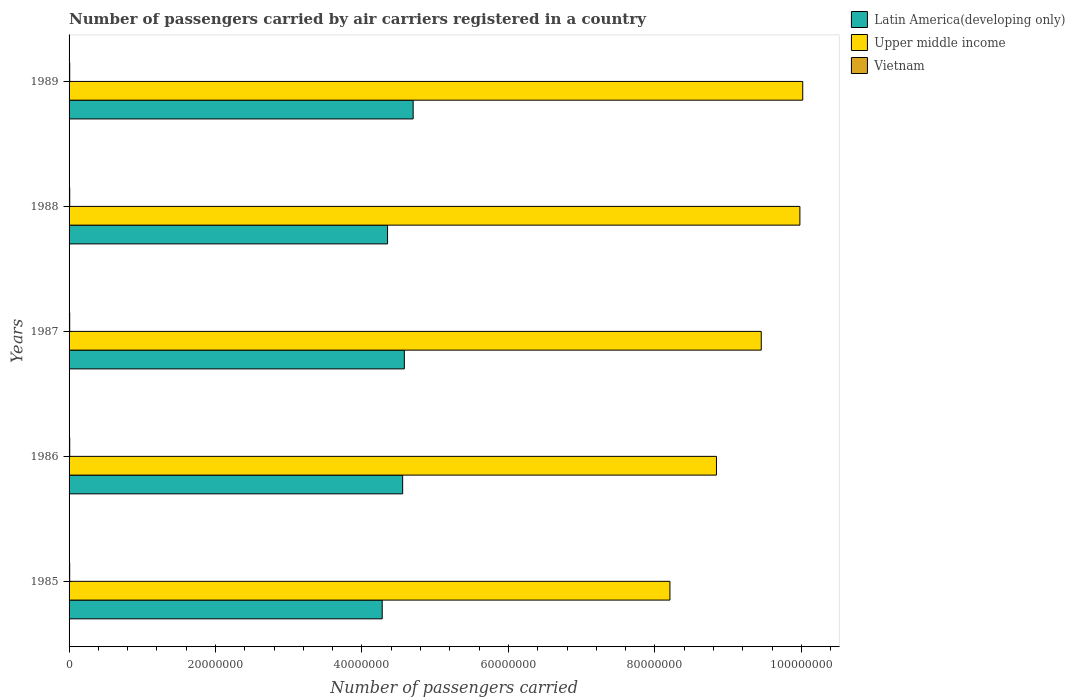Are the number of bars per tick equal to the number of legend labels?
Offer a very short reply. Yes. Are the number of bars on each tick of the Y-axis equal?
Your answer should be very brief. Yes. How many bars are there on the 3rd tick from the top?
Your answer should be compact. 3. What is the label of the 3rd group of bars from the top?
Provide a short and direct response. 1987. In how many cases, is the number of bars for a given year not equal to the number of legend labels?
Give a very brief answer. 0. What is the number of passengers carried by air carriers in Latin America(developing only) in 1985?
Make the answer very short. 4.28e+07. Across all years, what is the maximum number of passengers carried by air carriers in Upper middle income?
Keep it short and to the point. 1.00e+08. Across all years, what is the minimum number of passengers carried by air carriers in Upper middle income?
Give a very brief answer. 8.21e+07. In which year was the number of passengers carried by air carriers in Upper middle income minimum?
Keep it short and to the point. 1985. What is the total number of passengers carried by air carriers in Vietnam in the graph?
Make the answer very short. 4.35e+05. What is the difference between the number of passengers carried by air carriers in Latin America(developing only) in 1985 and that in 1989?
Ensure brevity in your answer.  -4.23e+06. What is the difference between the number of passengers carried by air carriers in Upper middle income in 1985 and the number of passengers carried by air carriers in Vietnam in 1986?
Provide a short and direct response. 8.20e+07. What is the average number of passengers carried by air carriers in Latin America(developing only) per year?
Ensure brevity in your answer.  4.49e+07. In the year 1988, what is the difference between the number of passengers carried by air carriers in Upper middle income and number of passengers carried by air carriers in Latin America(developing only)?
Provide a succinct answer. 5.63e+07. What is the ratio of the number of passengers carried by air carriers in Vietnam in 1987 to that in 1988?
Your answer should be very brief. 0.99. Is the number of passengers carried by air carriers in Latin America(developing only) in 1985 less than that in 1986?
Provide a short and direct response. Yes. What is the difference between the highest and the second highest number of passengers carried by air carriers in Latin America(developing only)?
Your answer should be compact. 1.20e+06. What is the difference between the highest and the lowest number of passengers carried by air carriers in Latin America(developing only)?
Keep it short and to the point. 4.23e+06. Is the sum of the number of passengers carried by air carriers in Vietnam in 1986 and 1987 greater than the maximum number of passengers carried by air carriers in Upper middle income across all years?
Ensure brevity in your answer.  No. What does the 3rd bar from the top in 1986 represents?
Ensure brevity in your answer.  Latin America(developing only). What does the 3rd bar from the bottom in 1985 represents?
Provide a short and direct response. Vietnam. Is it the case that in every year, the sum of the number of passengers carried by air carriers in Vietnam and number of passengers carried by air carriers in Upper middle income is greater than the number of passengers carried by air carriers in Latin America(developing only)?
Give a very brief answer. Yes. How many bars are there?
Your response must be concise. 15. How many years are there in the graph?
Offer a very short reply. 5. Are the values on the major ticks of X-axis written in scientific E-notation?
Provide a succinct answer. No. Does the graph contain any zero values?
Provide a succinct answer. No. How are the legend labels stacked?
Provide a short and direct response. Vertical. What is the title of the graph?
Ensure brevity in your answer.  Number of passengers carried by air carriers registered in a country. What is the label or title of the X-axis?
Provide a succinct answer. Number of passengers carried. What is the Number of passengers carried in Latin America(developing only) in 1985?
Your response must be concise. 4.28e+07. What is the Number of passengers carried of Upper middle income in 1985?
Offer a terse response. 8.21e+07. What is the Number of passengers carried in Vietnam in 1985?
Provide a succinct answer. 8.40e+04. What is the Number of passengers carried of Latin America(developing only) in 1986?
Provide a short and direct response. 4.56e+07. What is the Number of passengers carried in Upper middle income in 1986?
Ensure brevity in your answer.  8.84e+07. What is the Number of passengers carried in Vietnam in 1986?
Keep it short and to the point. 8.80e+04. What is the Number of passengers carried of Latin America(developing only) in 1987?
Your answer should be compact. 4.58e+07. What is the Number of passengers carried of Upper middle income in 1987?
Make the answer very short. 9.45e+07. What is the Number of passengers carried of Vietnam in 1987?
Your answer should be very brief. 8.70e+04. What is the Number of passengers carried of Latin America(developing only) in 1988?
Your response must be concise. 4.35e+07. What is the Number of passengers carried in Upper middle income in 1988?
Your response must be concise. 9.98e+07. What is the Number of passengers carried in Vietnam in 1988?
Provide a short and direct response. 8.78e+04. What is the Number of passengers carried of Latin America(developing only) in 1989?
Offer a terse response. 4.70e+07. What is the Number of passengers carried in Upper middle income in 1989?
Offer a very short reply. 1.00e+08. What is the Number of passengers carried in Vietnam in 1989?
Offer a very short reply. 8.82e+04. Across all years, what is the maximum Number of passengers carried of Latin America(developing only)?
Your answer should be very brief. 4.70e+07. Across all years, what is the maximum Number of passengers carried of Upper middle income?
Ensure brevity in your answer.  1.00e+08. Across all years, what is the maximum Number of passengers carried in Vietnam?
Your answer should be very brief. 8.82e+04. Across all years, what is the minimum Number of passengers carried in Latin America(developing only)?
Offer a terse response. 4.28e+07. Across all years, what is the minimum Number of passengers carried of Upper middle income?
Your answer should be compact. 8.21e+07. Across all years, what is the minimum Number of passengers carried of Vietnam?
Keep it short and to the point. 8.40e+04. What is the total Number of passengers carried of Latin America(developing only) in the graph?
Your answer should be very brief. 2.25e+08. What is the total Number of passengers carried in Upper middle income in the graph?
Keep it short and to the point. 4.65e+08. What is the total Number of passengers carried of Vietnam in the graph?
Ensure brevity in your answer.  4.35e+05. What is the difference between the Number of passengers carried in Latin America(developing only) in 1985 and that in 1986?
Offer a terse response. -2.79e+06. What is the difference between the Number of passengers carried of Upper middle income in 1985 and that in 1986?
Offer a terse response. -6.35e+06. What is the difference between the Number of passengers carried in Vietnam in 1985 and that in 1986?
Ensure brevity in your answer.  -4000. What is the difference between the Number of passengers carried in Latin America(developing only) in 1985 and that in 1987?
Your response must be concise. -3.02e+06. What is the difference between the Number of passengers carried of Upper middle income in 1985 and that in 1987?
Your answer should be compact. -1.25e+07. What is the difference between the Number of passengers carried of Vietnam in 1985 and that in 1987?
Make the answer very short. -3000. What is the difference between the Number of passengers carried of Latin America(developing only) in 1985 and that in 1988?
Give a very brief answer. -7.31e+05. What is the difference between the Number of passengers carried of Upper middle income in 1985 and that in 1988?
Keep it short and to the point. -1.77e+07. What is the difference between the Number of passengers carried of Vietnam in 1985 and that in 1988?
Your response must be concise. -3800. What is the difference between the Number of passengers carried of Latin America(developing only) in 1985 and that in 1989?
Make the answer very short. -4.23e+06. What is the difference between the Number of passengers carried of Upper middle income in 1985 and that in 1989?
Offer a very short reply. -1.81e+07. What is the difference between the Number of passengers carried of Vietnam in 1985 and that in 1989?
Give a very brief answer. -4200. What is the difference between the Number of passengers carried in Latin America(developing only) in 1986 and that in 1987?
Your answer should be compact. -2.29e+05. What is the difference between the Number of passengers carried of Upper middle income in 1986 and that in 1987?
Your answer should be compact. -6.12e+06. What is the difference between the Number of passengers carried of Latin America(developing only) in 1986 and that in 1988?
Provide a succinct answer. 2.06e+06. What is the difference between the Number of passengers carried in Upper middle income in 1986 and that in 1988?
Keep it short and to the point. -1.14e+07. What is the difference between the Number of passengers carried in Vietnam in 1986 and that in 1988?
Make the answer very short. 200. What is the difference between the Number of passengers carried in Latin America(developing only) in 1986 and that in 1989?
Ensure brevity in your answer.  -1.43e+06. What is the difference between the Number of passengers carried in Upper middle income in 1986 and that in 1989?
Make the answer very short. -1.18e+07. What is the difference between the Number of passengers carried of Vietnam in 1986 and that in 1989?
Offer a terse response. -200. What is the difference between the Number of passengers carried in Latin America(developing only) in 1987 and that in 1988?
Give a very brief answer. 2.29e+06. What is the difference between the Number of passengers carried in Upper middle income in 1987 and that in 1988?
Give a very brief answer. -5.28e+06. What is the difference between the Number of passengers carried in Vietnam in 1987 and that in 1988?
Provide a succinct answer. -800. What is the difference between the Number of passengers carried in Latin America(developing only) in 1987 and that in 1989?
Make the answer very short. -1.20e+06. What is the difference between the Number of passengers carried of Upper middle income in 1987 and that in 1989?
Your answer should be very brief. -5.66e+06. What is the difference between the Number of passengers carried in Vietnam in 1987 and that in 1989?
Give a very brief answer. -1200. What is the difference between the Number of passengers carried in Latin America(developing only) in 1988 and that in 1989?
Your response must be concise. -3.49e+06. What is the difference between the Number of passengers carried in Upper middle income in 1988 and that in 1989?
Your response must be concise. -3.87e+05. What is the difference between the Number of passengers carried of Vietnam in 1988 and that in 1989?
Give a very brief answer. -400. What is the difference between the Number of passengers carried in Latin America(developing only) in 1985 and the Number of passengers carried in Upper middle income in 1986?
Provide a succinct answer. -4.56e+07. What is the difference between the Number of passengers carried in Latin America(developing only) in 1985 and the Number of passengers carried in Vietnam in 1986?
Your response must be concise. 4.27e+07. What is the difference between the Number of passengers carried of Upper middle income in 1985 and the Number of passengers carried of Vietnam in 1986?
Your answer should be compact. 8.20e+07. What is the difference between the Number of passengers carried of Latin America(developing only) in 1985 and the Number of passengers carried of Upper middle income in 1987?
Offer a very short reply. -5.18e+07. What is the difference between the Number of passengers carried in Latin America(developing only) in 1985 and the Number of passengers carried in Vietnam in 1987?
Your response must be concise. 4.27e+07. What is the difference between the Number of passengers carried in Upper middle income in 1985 and the Number of passengers carried in Vietnam in 1987?
Your answer should be compact. 8.20e+07. What is the difference between the Number of passengers carried in Latin America(developing only) in 1985 and the Number of passengers carried in Upper middle income in 1988?
Make the answer very short. -5.70e+07. What is the difference between the Number of passengers carried in Latin America(developing only) in 1985 and the Number of passengers carried in Vietnam in 1988?
Give a very brief answer. 4.27e+07. What is the difference between the Number of passengers carried in Upper middle income in 1985 and the Number of passengers carried in Vietnam in 1988?
Offer a very short reply. 8.20e+07. What is the difference between the Number of passengers carried of Latin America(developing only) in 1985 and the Number of passengers carried of Upper middle income in 1989?
Ensure brevity in your answer.  -5.74e+07. What is the difference between the Number of passengers carried in Latin America(developing only) in 1985 and the Number of passengers carried in Vietnam in 1989?
Your response must be concise. 4.27e+07. What is the difference between the Number of passengers carried in Upper middle income in 1985 and the Number of passengers carried in Vietnam in 1989?
Your answer should be compact. 8.20e+07. What is the difference between the Number of passengers carried in Latin America(developing only) in 1986 and the Number of passengers carried in Upper middle income in 1987?
Your response must be concise. -4.90e+07. What is the difference between the Number of passengers carried of Latin America(developing only) in 1986 and the Number of passengers carried of Vietnam in 1987?
Ensure brevity in your answer.  4.55e+07. What is the difference between the Number of passengers carried of Upper middle income in 1986 and the Number of passengers carried of Vietnam in 1987?
Give a very brief answer. 8.83e+07. What is the difference between the Number of passengers carried in Latin America(developing only) in 1986 and the Number of passengers carried in Upper middle income in 1988?
Provide a short and direct response. -5.42e+07. What is the difference between the Number of passengers carried of Latin America(developing only) in 1986 and the Number of passengers carried of Vietnam in 1988?
Provide a succinct answer. 4.55e+07. What is the difference between the Number of passengers carried of Upper middle income in 1986 and the Number of passengers carried of Vietnam in 1988?
Give a very brief answer. 8.83e+07. What is the difference between the Number of passengers carried of Latin America(developing only) in 1986 and the Number of passengers carried of Upper middle income in 1989?
Make the answer very short. -5.46e+07. What is the difference between the Number of passengers carried in Latin America(developing only) in 1986 and the Number of passengers carried in Vietnam in 1989?
Give a very brief answer. 4.55e+07. What is the difference between the Number of passengers carried in Upper middle income in 1986 and the Number of passengers carried in Vietnam in 1989?
Your answer should be very brief. 8.83e+07. What is the difference between the Number of passengers carried in Latin America(developing only) in 1987 and the Number of passengers carried in Upper middle income in 1988?
Provide a short and direct response. -5.40e+07. What is the difference between the Number of passengers carried of Latin America(developing only) in 1987 and the Number of passengers carried of Vietnam in 1988?
Your answer should be compact. 4.57e+07. What is the difference between the Number of passengers carried of Upper middle income in 1987 and the Number of passengers carried of Vietnam in 1988?
Make the answer very short. 9.44e+07. What is the difference between the Number of passengers carried in Latin America(developing only) in 1987 and the Number of passengers carried in Upper middle income in 1989?
Your response must be concise. -5.44e+07. What is the difference between the Number of passengers carried of Latin America(developing only) in 1987 and the Number of passengers carried of Vietnam in 1989?
Your response must be concise. 4.57e+07. What is the difference between the Number of passengers carried in Upper middle income in 1987 and the Number of passengers carried in Vietnam in 1989?
Your answer should be compact. 9.44e+07. What is the difference between the Number of passengers carried in Latin America(developing only) in 1988 and the Number of passengers carried in Upper middle income in 1989?
Keep it short and to the point. -5.67e+07. What is the difference between the Number of passengers carried of Latin America(developing only) in 1988 and the Number of passengers carried of Vietnam in 1989?
Provide a short and direct response. 4.34e+07. What is the difference between the Number of passengers carried in Upper middle income in 1988 and the Number of passengers carried in Vietnam in 1989?
Your answer should be very brief. 9.97e+07. What is the average Number of passengers carried of Latin America(developing only) per year?
Your response must be concise. 4.49e+07. What is the average Number of passengers carried of Upper middle income per year?
Give a very brief answer. 9.30e+07. What is the average Number of passengers carried in Vietnam per year?
Your answer should be very brief. 8.70e+04. In the year 1985, what is the difference between the Number of passengers carried of Latin America(developing only) and Number of passengers carried of Upper middle income?
Your response must be concise. -3.93e+07. In the year 1985, what is the difference between the Number of passengers carried of Latin America(developing only) and Number of passengers carried of Vietnam?
Offer a very short reply. 4.27e+07. In the year 1985, what is the difference between the Number of passengers carried in Upper middle income and Number of passengers carried in Vietnam?
Provide a succinct answer. 8.20e+07. In the year 1986, what is the difference between the Number of passengers carried of Latin America(developing only) and Number of passengers carried of Upper middle income?
Provide a succinct answer. -4.29e+07. In the year 1986, what is the difference between the Number of passengers carried in Latin America(developing only) and Number of passengers carried in Vietnam?
Make the answer very short. 4.55e+07. In the year 1986, what is the difference between the Number of passengers carried of Upper middle income and Number of passengers carried of Vietnam?
Offer a terse response. 8.83e+07. In the year 1987, what is the difference between the Number of passengers carried of Latin America(developing only) and Number of passengers carried of Upper middle income?
Give a very brief answer. -4.87e+07. In the year 1987, what is the difference between the Number of passengers carried in Latin America(developing only) and Number of passengers carried in Vietnam?
Make the answer very short. 4.57e+07. In the year 1987, what is the difference between the Number of passengers carried of Upper middle income and Number of passengers carried of Vietnam?
Keep it short and to the point. 9.44e+07. In the year 1988, what is the difference between the Number of passengers carried of Latin America(developing only) and Number of passengers carried of Upper middle income?
Make the answer very short. -5.63e+07. In the year 1988, what is the difference between the Number of passengers carried of Latin America(developing only) and Number of passengers carried of Vietnam?
Your answer should be compact. 4.34e+07. In the year 1988, what is the difference between the Number of passengers carried of Upper middle income and Number of passengers carried of Vietnam?
Offer a very short reply. 9.97e+07. In the year 1989, what is the difference between the Number of passengers carried in Latin America(developing only) and Number of passengers carried in Upper middle income?
Ensure brevity in your answer.  -5.32e+07. In the year 1989, what is the difference between the Number of passengers carried of Latin America(developing only) and Number of passengers carried of Vietnam?
Provide a succinct answer. 4.69e+07. In the year 1989, what is the difference between the Number of passengers carried of Upper middle income and Number of passengers carried of Vietnam?
Offer a terse response. 1.00e+08. What is the ratio of the Number of passengers carried in Latin America(developing only) in 1985 to that in 1986?
Your response must be concise. 0.94. What is the ratio of the Number of passengers carried of Upper middle income in 1985 to that in 1986?
Your response must be concise. 0.93. What is the ratio of the Number of passengers carried of Vietnam in 1985 to that in 1986?
Give a very brief answer. 0.95. What is the ratio of the Number of passengers carried in Latin America(developing only) in 1985 to that in 1987?
Give a very brief answer. 0.93. What is the ratio of the Number of passengers carried of Upper middle income in 1985 to that in 1987?
Offer a very short reply. 0.87. What is the ratio of the Number of passengers carried of Vietnam in 1985 to that in 1987?
Your answer should be very brief. 0.97. What is the ratio of the Number of passengers carried of Latin America(developing only) in 1985 to that in 1988?
Provide a short and direct response. 0.98. What is the ratio of the Number of passengers carried in Upper middle income in 1985 to that in 1988?
Give a very brief answer. 0.82. What is the ratio of the Number of passengers carried of Vietnam in 1985 to that in 1988?
Offer a very short reply. 0.96. What is the ratio of the Number of passengers carried in Latin America(developing only) in 1985 to that in 1989?
Keep it short and to the point. 0.91. What is the ratio of the Number of passengers carried of Upper middle income in 1985 to that in 1989?
Offer a very short reply. 0.82. What is the ratio of the Number of passengers carried of Vietnam in 1985 to that in 1989?
Provide a succinct answer. 0.95. What is the ratio of the Number of passengers carried in Upper middle income in 1986 to that in 1987?
Your answer should be very brief. 0.94. What is the ratio of the Number of passengers carried in Vietnam in 1986 to that in 1987?
Give a very brief answer. 1.01. What is the ratio of the Number of passengers carried in Latin America(developing only) in 1986 to that in 1988?
Your answer should be compact. 1.05. What is the ratio of the Number of passengers carried in Upper middle income in 1986 to that in 1988?
Provide a succinct answer. 0.89. What is the ratio of the Number of passengers carried of Vietnam in 1986 to that in 1988?
Provide a succinct answer. 1. What is the ratio of the Number of passengers carried of Latin America(developing only) in 1986 to that in 1989?
Offer a very short reply. 0.97. What is the ratio of the Number of passengers carried in Upper middle income in 1986 to that in 1989?
Ensure brevity in your answer.  0.88. What is the ratio of the Number of passengers carried in Latin America(developing only) in 1987 to that in 1988?
Your answer should be compact. 1.05. What is the ratio of the Number of passengers carried of Upper middle income in 1987 to that in 1988?
Offer a terse response. 0.95. What is the ratio of the Number of passengers carried of Vietnam in 1987 to that in 1988?
Make the answer very short. 0.99. What is the ratio of the Number of passengers carried of Latin America(developing only) in 1987 to that in 1989?
Your answer should be very brief. 0.97. What is the ratio of the Number of passengers carried in Upper middle income in 1987 to that in 1989?
Give a very brief answer. 0.94. What is the ratio of the Number of passengers carried of Vietnam in 1987 to that in 1989?
Ensure brevity in your answer.  0.99. What is the ratio of the Number of passengers carried in Latin America(developing only) in 1988 to that in 1989?
Your response must be concise. 0.93. What is the ratio of the Number of passengers carried in Upper middle income in 1988 to that in 1989?
Your response must be concise. 1. What is the difference between the highest and the second highest Number of passengers carried in Latin America(developing only)?
Make the answer very short. 1.20e+06. What is the difference between the highest and the second highest Number of passengers carried in Upper middle income?
Provide a succinct answer. 3.87e+05. What is the difference between the highest and the second highest Number of passengers carried of Vietnam?
Keep it short and to the point. 200. What is the difference between the highest and the lowest Number of passengers carried of Latin America(developing only)?
Your answer should be compact. 4.23e+06. What is the difference between the highest and the lowest Number of passengers carried of Upper middle income?
Keep it short and to the point. 1.81e+07. What is the difference between the highest and the lowest Number of passengers carried of Vietnam?
Keep it short and to the point. 4200. 